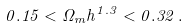Convert formula to latex. <formula><loc_0><loc_0><loc_500><loc_500>0 . 1 5 < \Omega _ { m } h ^ { 1 . 3 } < 0 . 3 2 \, .</formula> 